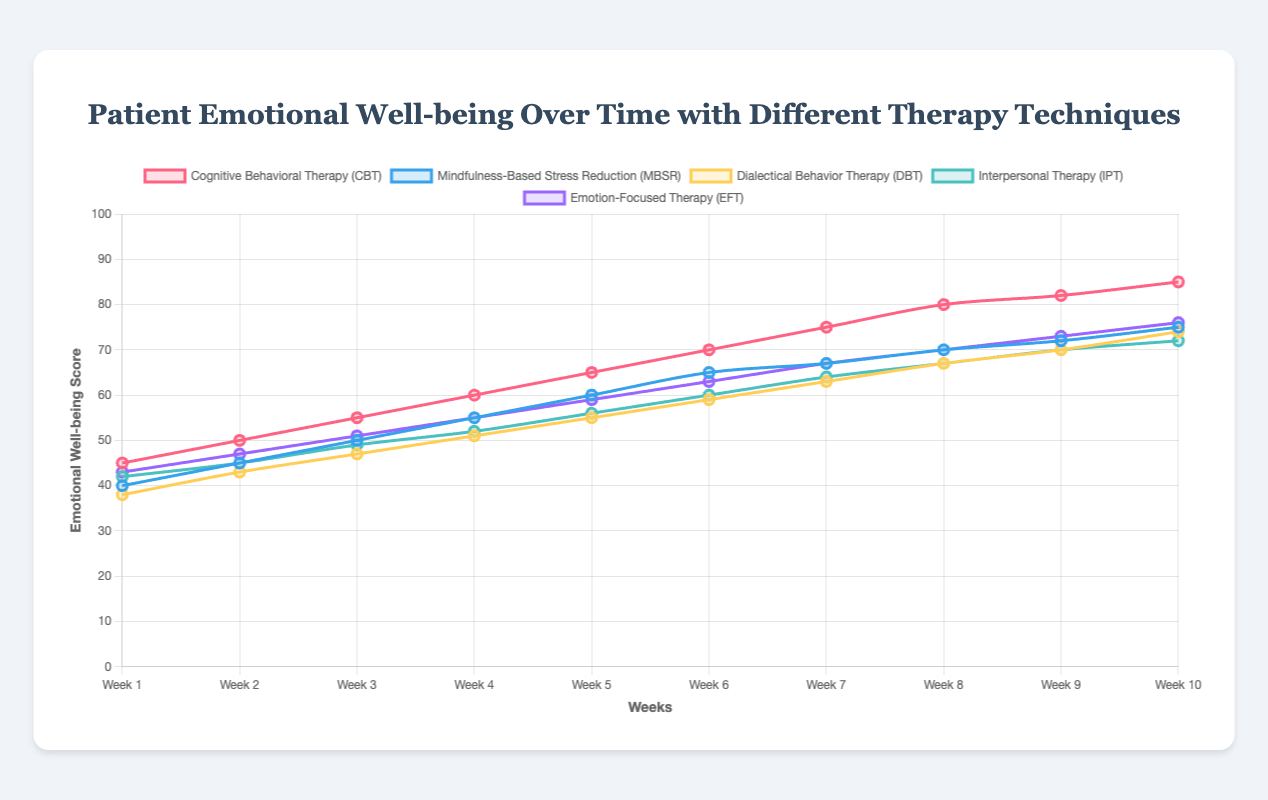What's the initial emotional well-being score of patients in Cognitive Behavioral Therapy (CBT)? The initial score for CBT can be found by looking at the value at week 1 for the CBT line, which is 45.
Answer: 45 How does the emotional well-being score change for Dialectical Behavior Therapy (DBT) from week 1 to week 10? Check the DBT line and note the difference between the scores at week 1 (38) and week 10 (74). The change is 74 - 38 = 36.
Answer: 36 Compare the emotional well-being scores of Mindfulness-Based Stress Reduction (MBSR) and Emotion-Focused Therapy (EFT) in week 5. Which one is higher? Locate the week 5 scores for both MBSR and EFT. MBSR's score is 60 and EFT's score is 59. Therefore, MBSR is higher.
Answer: MBSR For Cognitive Behavioral Therapy (CBT), what is the average emotional well-being score over the 10 weeks? Sum all scores for CBT and divide by 10: (45 + 50 + 55 + 60 + 65 + 70 + 75 + 80 + 82 + 85) / 10 = 66.7.
Answer: 66.7 Which therapy technique shows the steepest increase in emotional well-being scores between any two consecutive weeks? Identify the steepest increase by examining the score differences between consecutive weeks for all techniques. The steepest increase is from week 7 to week 8 for CBT (5 points: 75 to 80).
Answer: CBT What are the colors representing Mindfulness-Based Stress Reduction (MBSR) and Interpersonal Therapy (IPT) lines? The MBSR line is blue, and the IPT line is green based on the color descriptions given in the code.
Answer: blue and green Between weeks 4 and 5, what is the combined increase in emotional well-being scores for CBT and DBT? Calculate the increase for both CBT (60 to 65 = 5) and DBT (51 to 55 = 4). Combined increase is 5 + 4 = 9.
Answer: 9 During which week does Emotion-Focused Therapy (EFT) first surpass a score of 70? Locate the week where the EFT line first goes above 70. This occurs at week 9.
Answer: week 9 